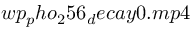<formula> <loc_0><loc_0><loc_500><loc_500>w p _ { p } h o _ { 2 } 5 6 _ { d } e c a y 0 . m p 4</formula> 